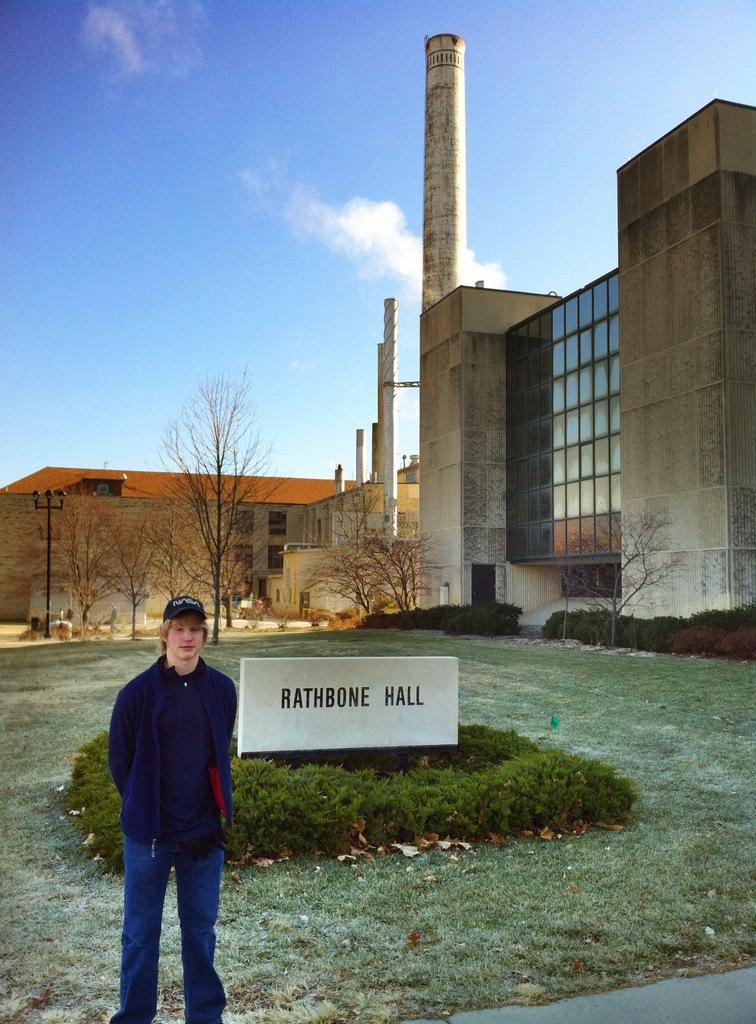How would you summarize this image in a sentence or two? This image is taken outdoors. At the top of the image there is a sky with clouds. At the bottom of the image there is a ground with grass on it. On the left side of the image a man is standing on the ground. In the middle of the image there are a few plants and there is a board with a text on it. In the background there are a few buildings with walls, windows, doors and roofs. There are a few poles and there is a tower. There are a few trees and plants. 